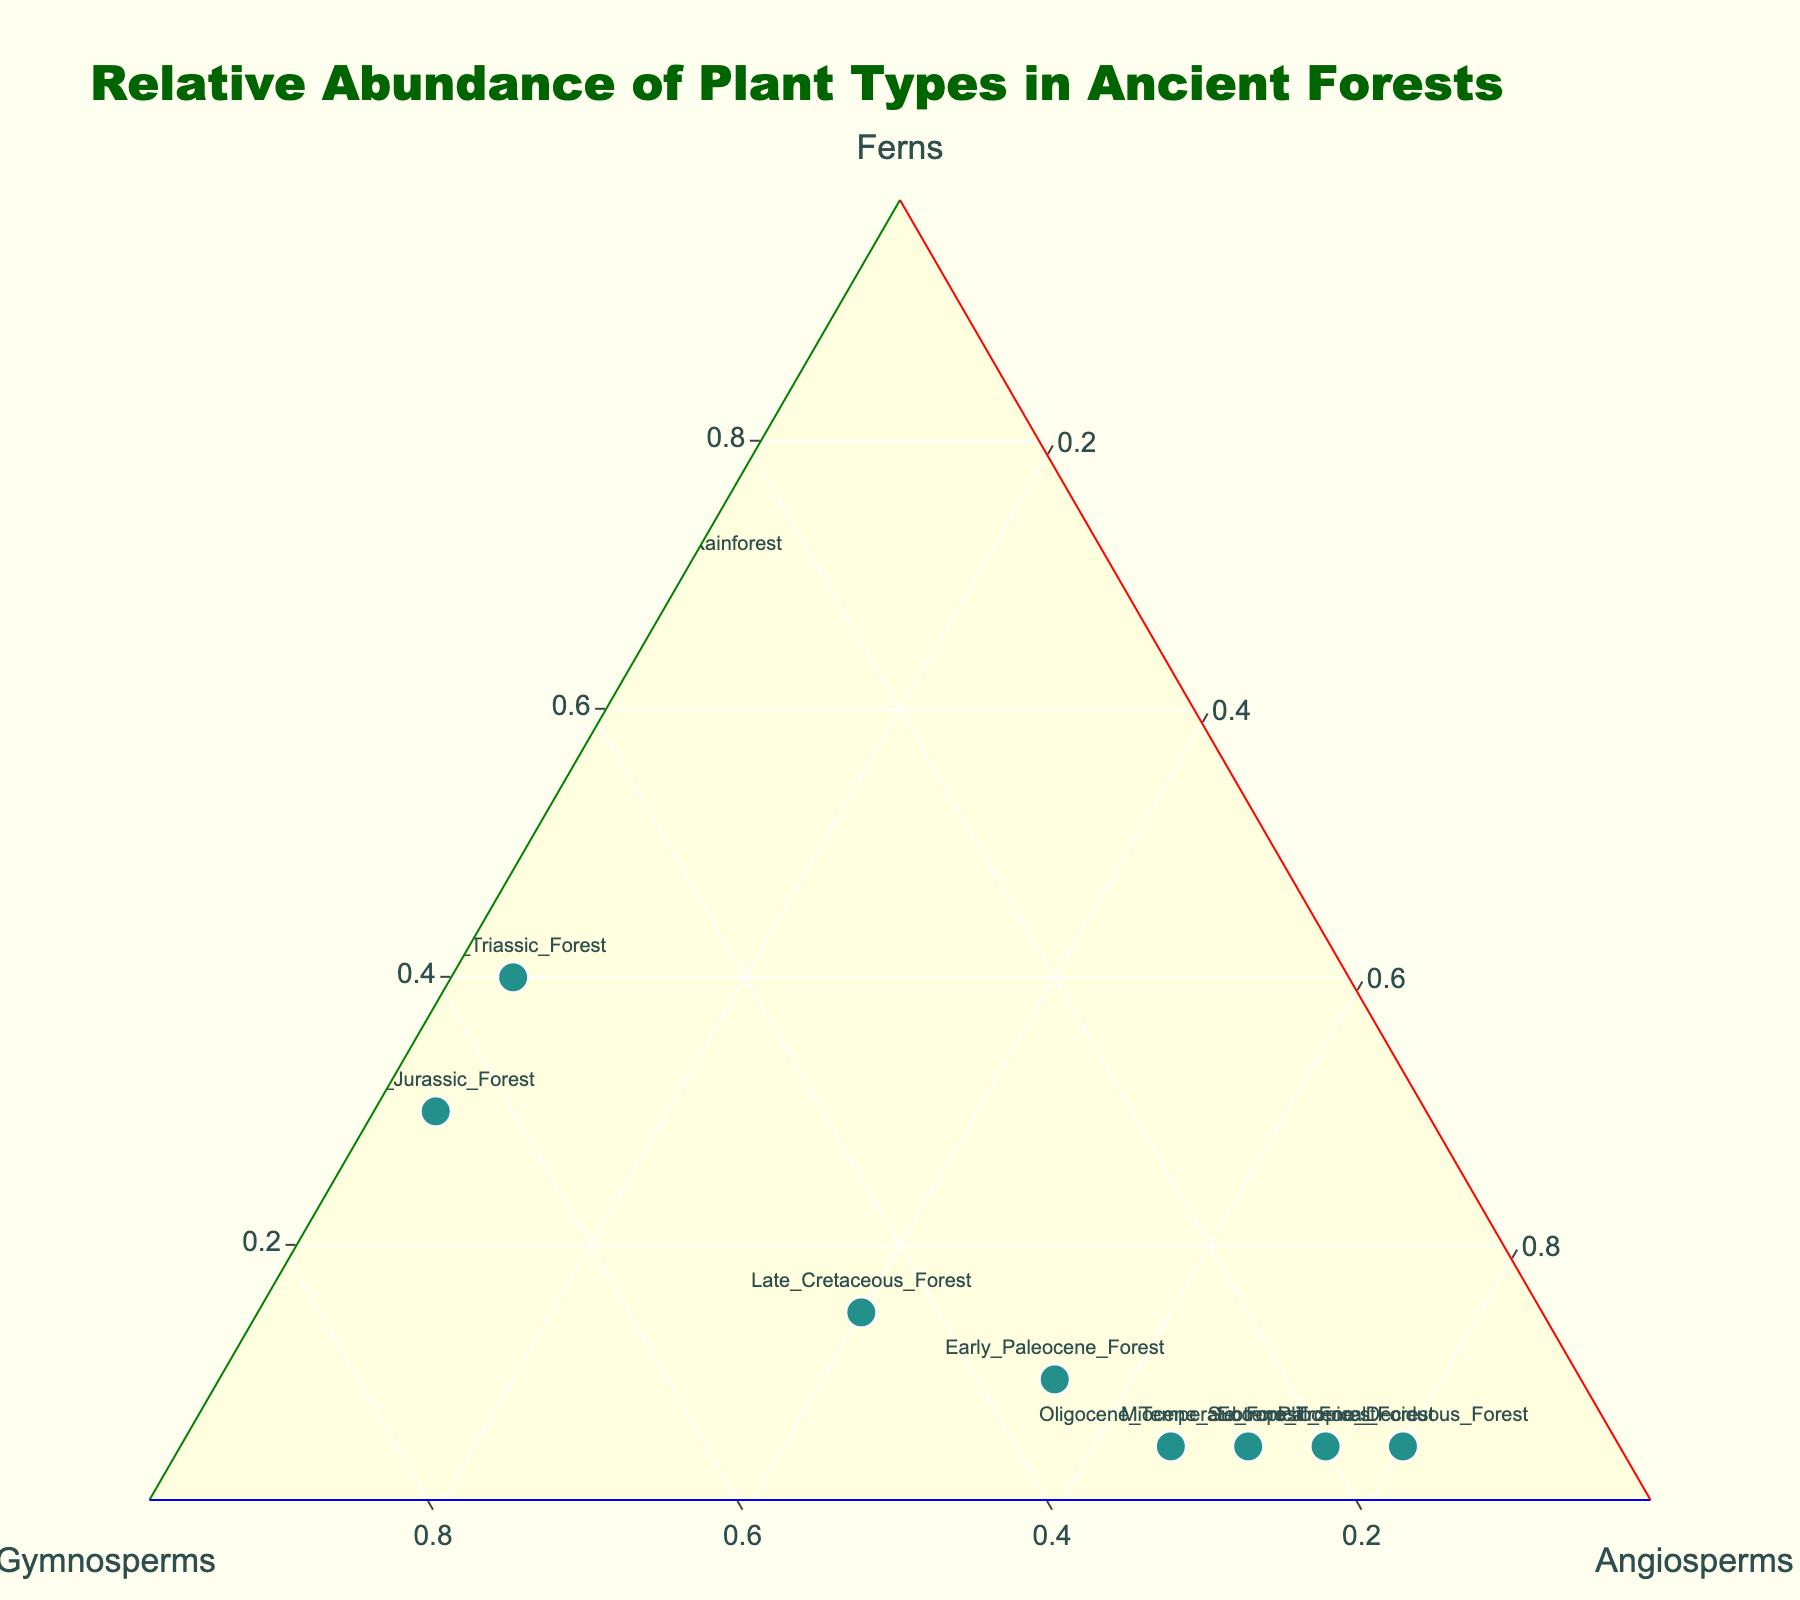**What's the title of the figure?** The title is prominently displayed at the top of the figure in large, bold text.
Answer: Relative Abundance of Plant Types in Ancient Forests **How many data points are shown in the plot?** Each marker in the plot represents a forest type, and their labels are visible. Counting the labeled markers gives the number of data points.
Answer: 9 **What color represents the lowest total abundance of plant types?** The color of the markers represents the total abundance, and we look for the lightest color on the scale used in the plot, which is in the 'Viridis' colorscale (light yellow for low values).
Answer: Light yellow **Which forest type has the highest relative abundance of angiosperms?** We identify the marker positioned closest to the 'Angiosperms' vertex of the ternary plot. This marker should be labeled.
Answer: Pliocene Deciduous Forest **How much did the relative abundance of ferns decrease between the Carboniferous Rainforest and Late Cretaceous Forest?** Calculate the difference between the normalized values of ferns for these two periods based on their positions in the plot. Carboniferous Rainforest has the highest relative fern abundance and Late Cretaceous Forest much lower.
Answer: 55% (70% - 15%) **Which forest type shows a relative abundance of 5% for both ferns and gymnosperms?** Locate the marker where both the 'a' axis (ferns) and 'b' axis (gymnosperms) values are approximately 0.05.
Answer: Oligocene Temperate Forest **Which forest type shows an equal proportion of gymnosperms and angiosperms?** Identify the marker where the 'b' (gymnosperms) and 'c' (angiosperms) axis values are nearly identical.
Answer: Early Jurassic Forest (both gymnosperms and angiosperms are 65%) **What is the relative change in the proportion of gymnosperms from Late Triassic Forest to Miocene Subtropical Forest?** Subtract the relative proportion of gymnosperms in the Miocene Subtropical Forest from its proportion in the Late Triassic Forest, based on ternary plot positions.
Answer: 30% (55% - 25%) **Which two forest types have a similar proportion of ferns but different proportions of gymnosperms and angiosperms?** Identify markers that have similar 'a' axis values (ferns) but different positions along the 'b' (gymnosperms) and 'c' (angiosperms) axes. The likely candidates are Miocene Subtropical Forest and Oligocene Temperate Forest based on their ferns’ relative abundance being 5%.
Answer: Miocene Subtropical Forest and Oligocene Temperate Forest **Across all forest types, which plant group shows the most consistent trend in relative abundance over time?** Observe the spread of markers along the axes of the ternary plot and identify the plant group axis with the least variation. Gymnosperms remain relatively high throughout the different forest types, while ferns and angiosperms show more variability.
Answer: Gymnosperms 